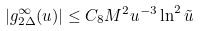Convert formula to latex. <formula><loc_0><loc_0><loc_500><loc_500>\left | g _ { 2 \Delta } ^ { \infty } ( u ) \right | \leq C _ { 8 } M ^ { 2 } u ^ { - 3 } \ln ^ { 2 } \tilde { u }</formula> 